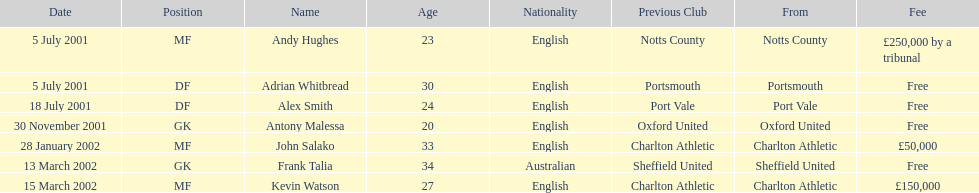What is the complete count of free costs? 4. 